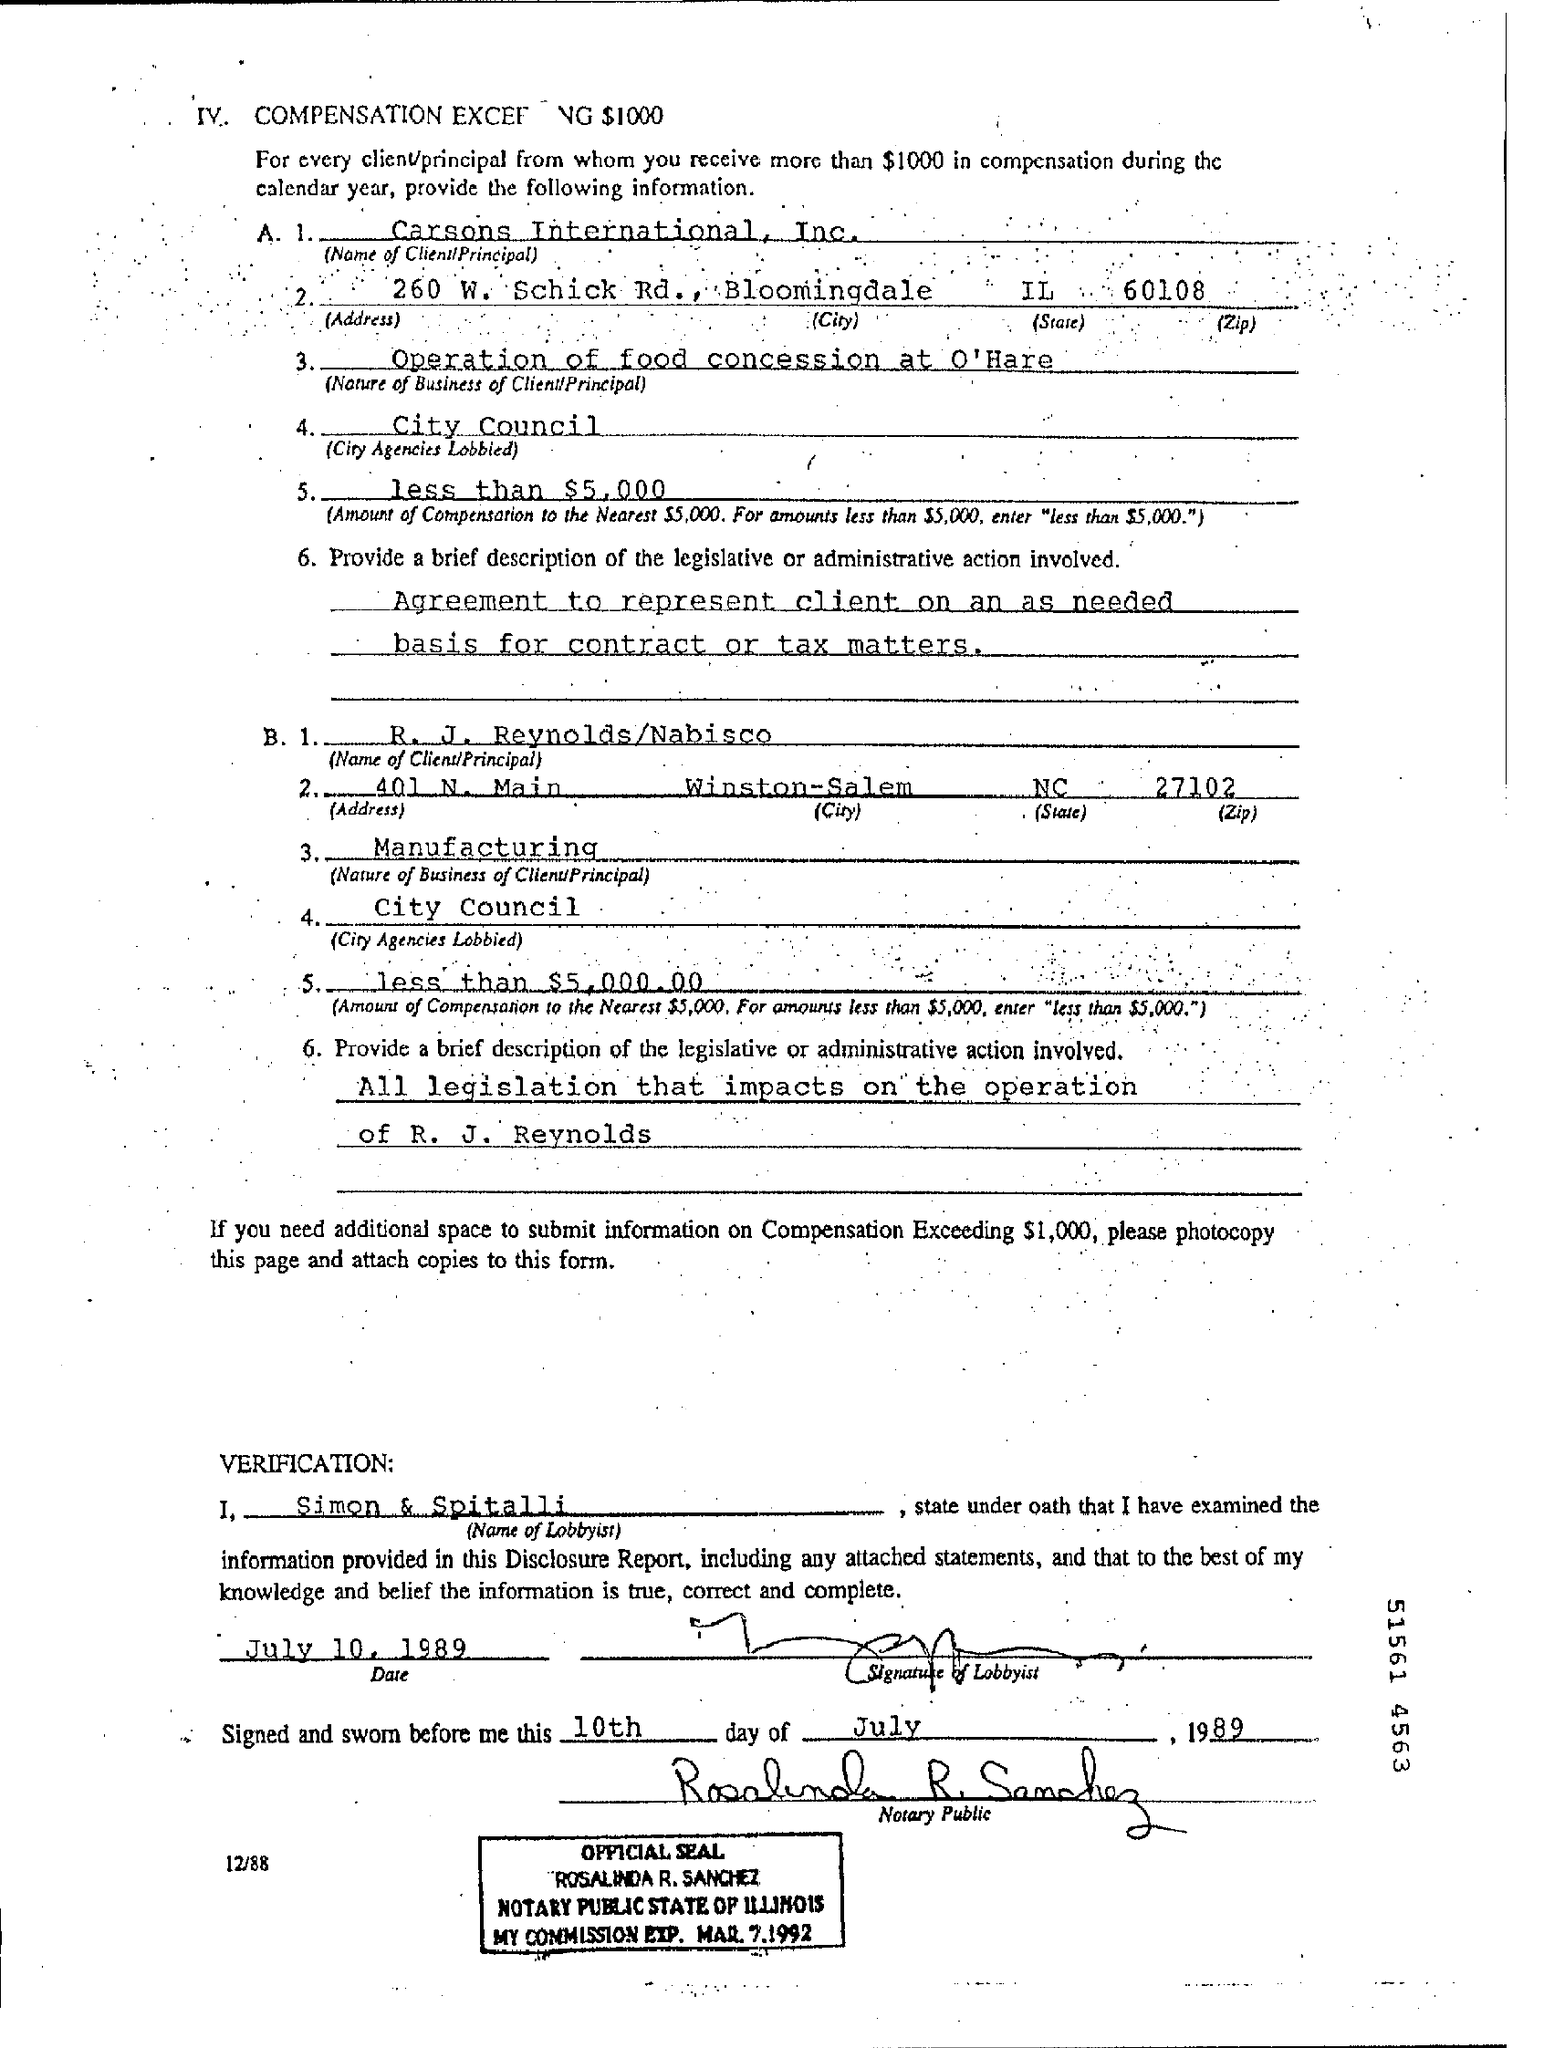What is the name of 1st client?
Provide a succinct answer. Carsons International , Inc. How many dollar were recieved in compensation from Carsons?
Offer a terse response. Less than $5,000. Where the 2nd Client from (city)?
Provide a succinct answer. Winston-Salem. Name of Lobbyist who examined the information provided?
Keep it short and to the point. Simon & Spitalli. 